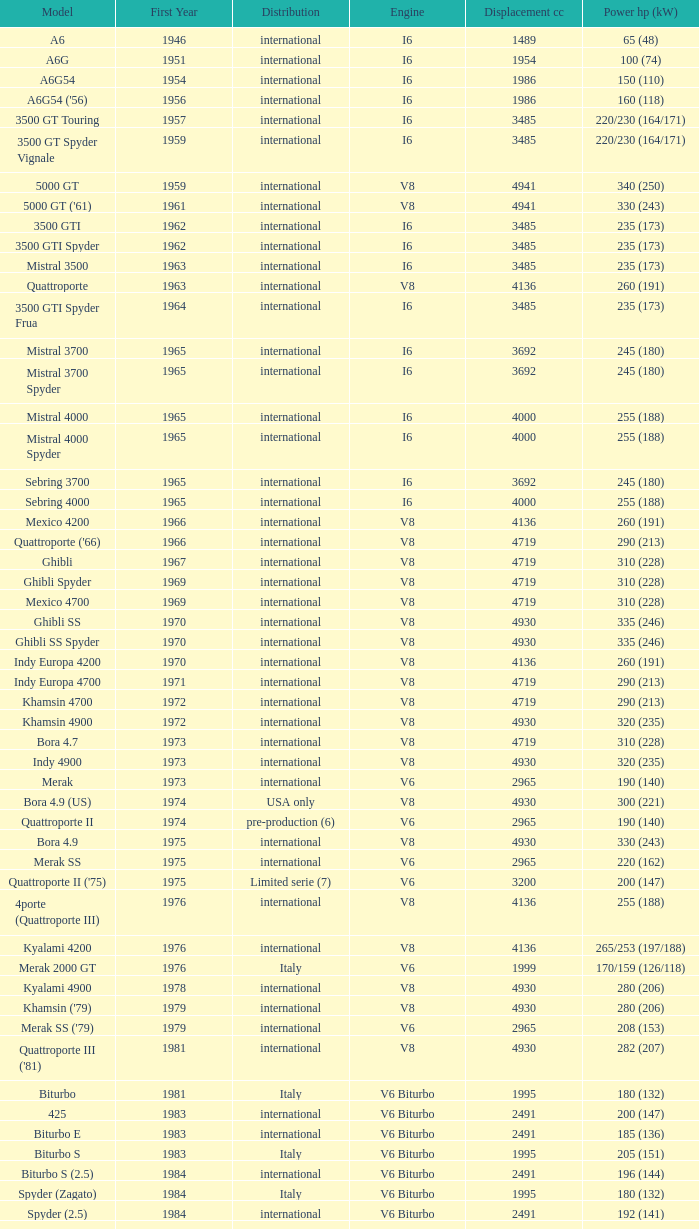What is the overall count of first year, when displacement cc exceeds 4719, when engine is v8, when power hp (kw) is "335 (246)", and when model is "ghibli ss"? 1.0. 